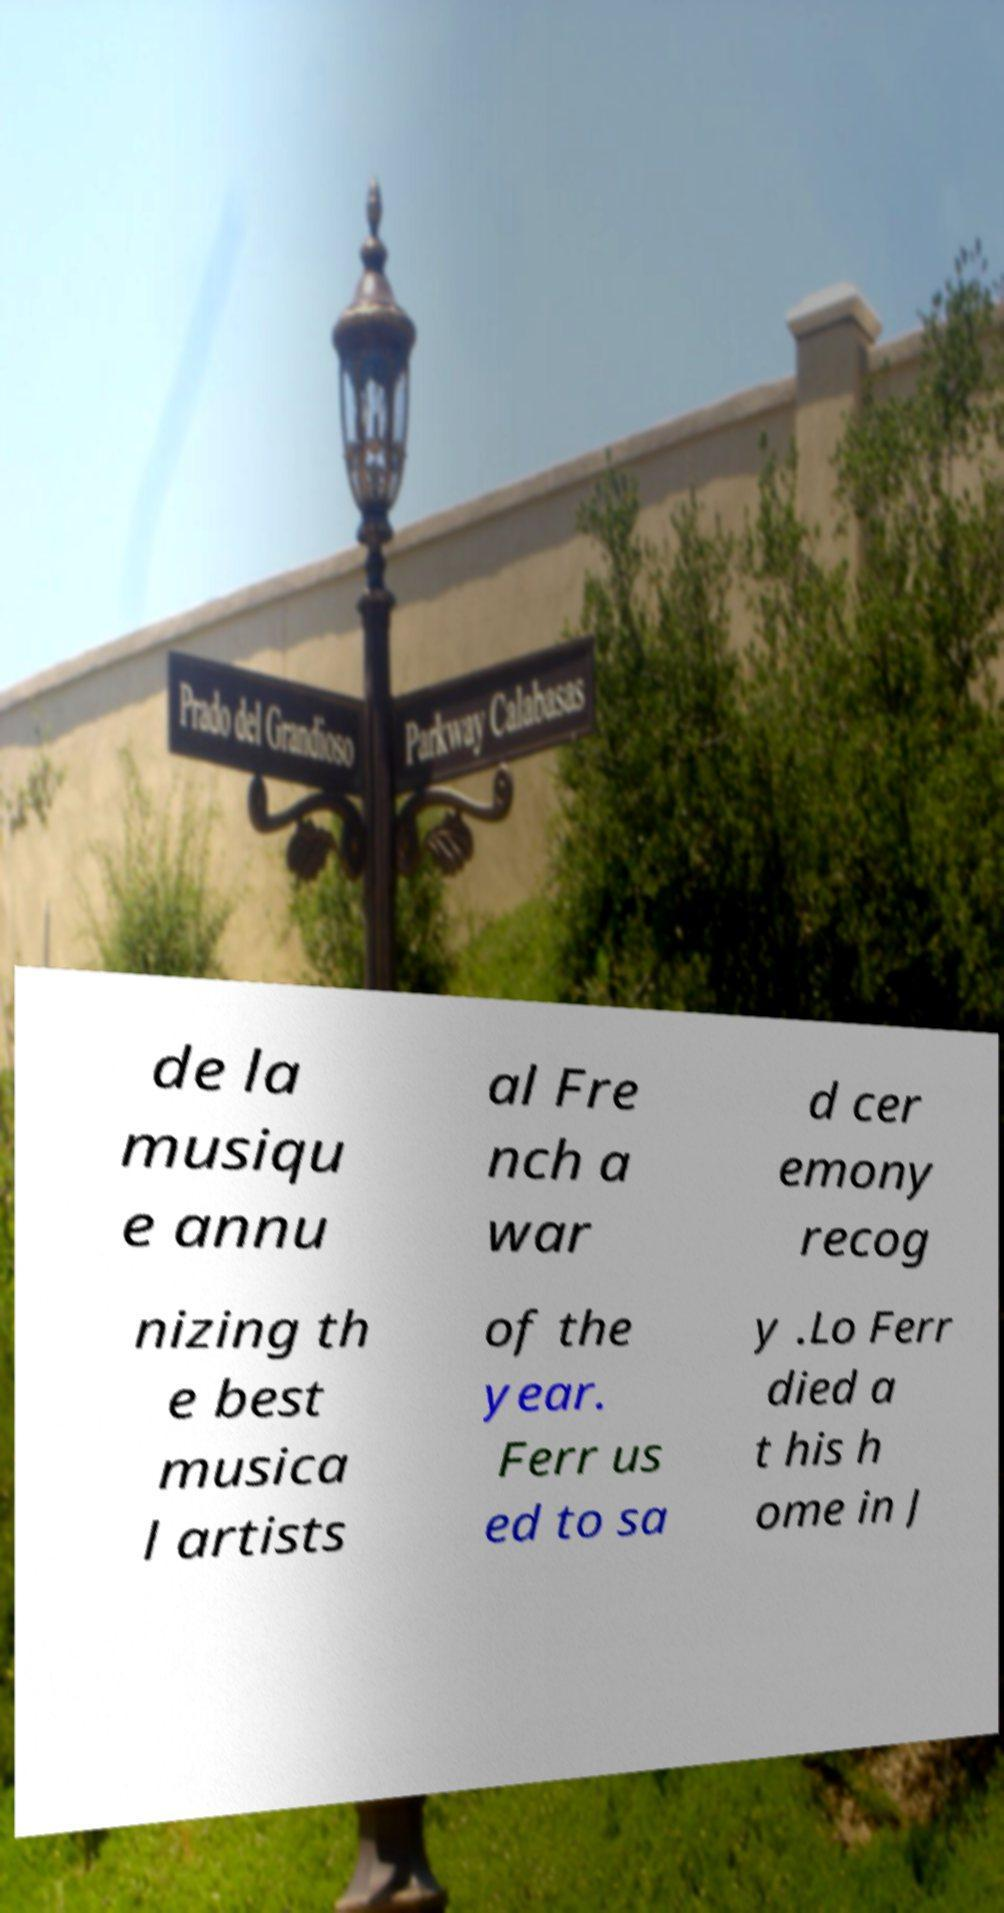Please read and relay the text visible in this image. What does it say? de la musiqu e annu al Fre nch a war d cer emony recog nizing th e best musica l artists of the year. Ferr us ed to sa y .Lo Ferr died a t his h ome in J 